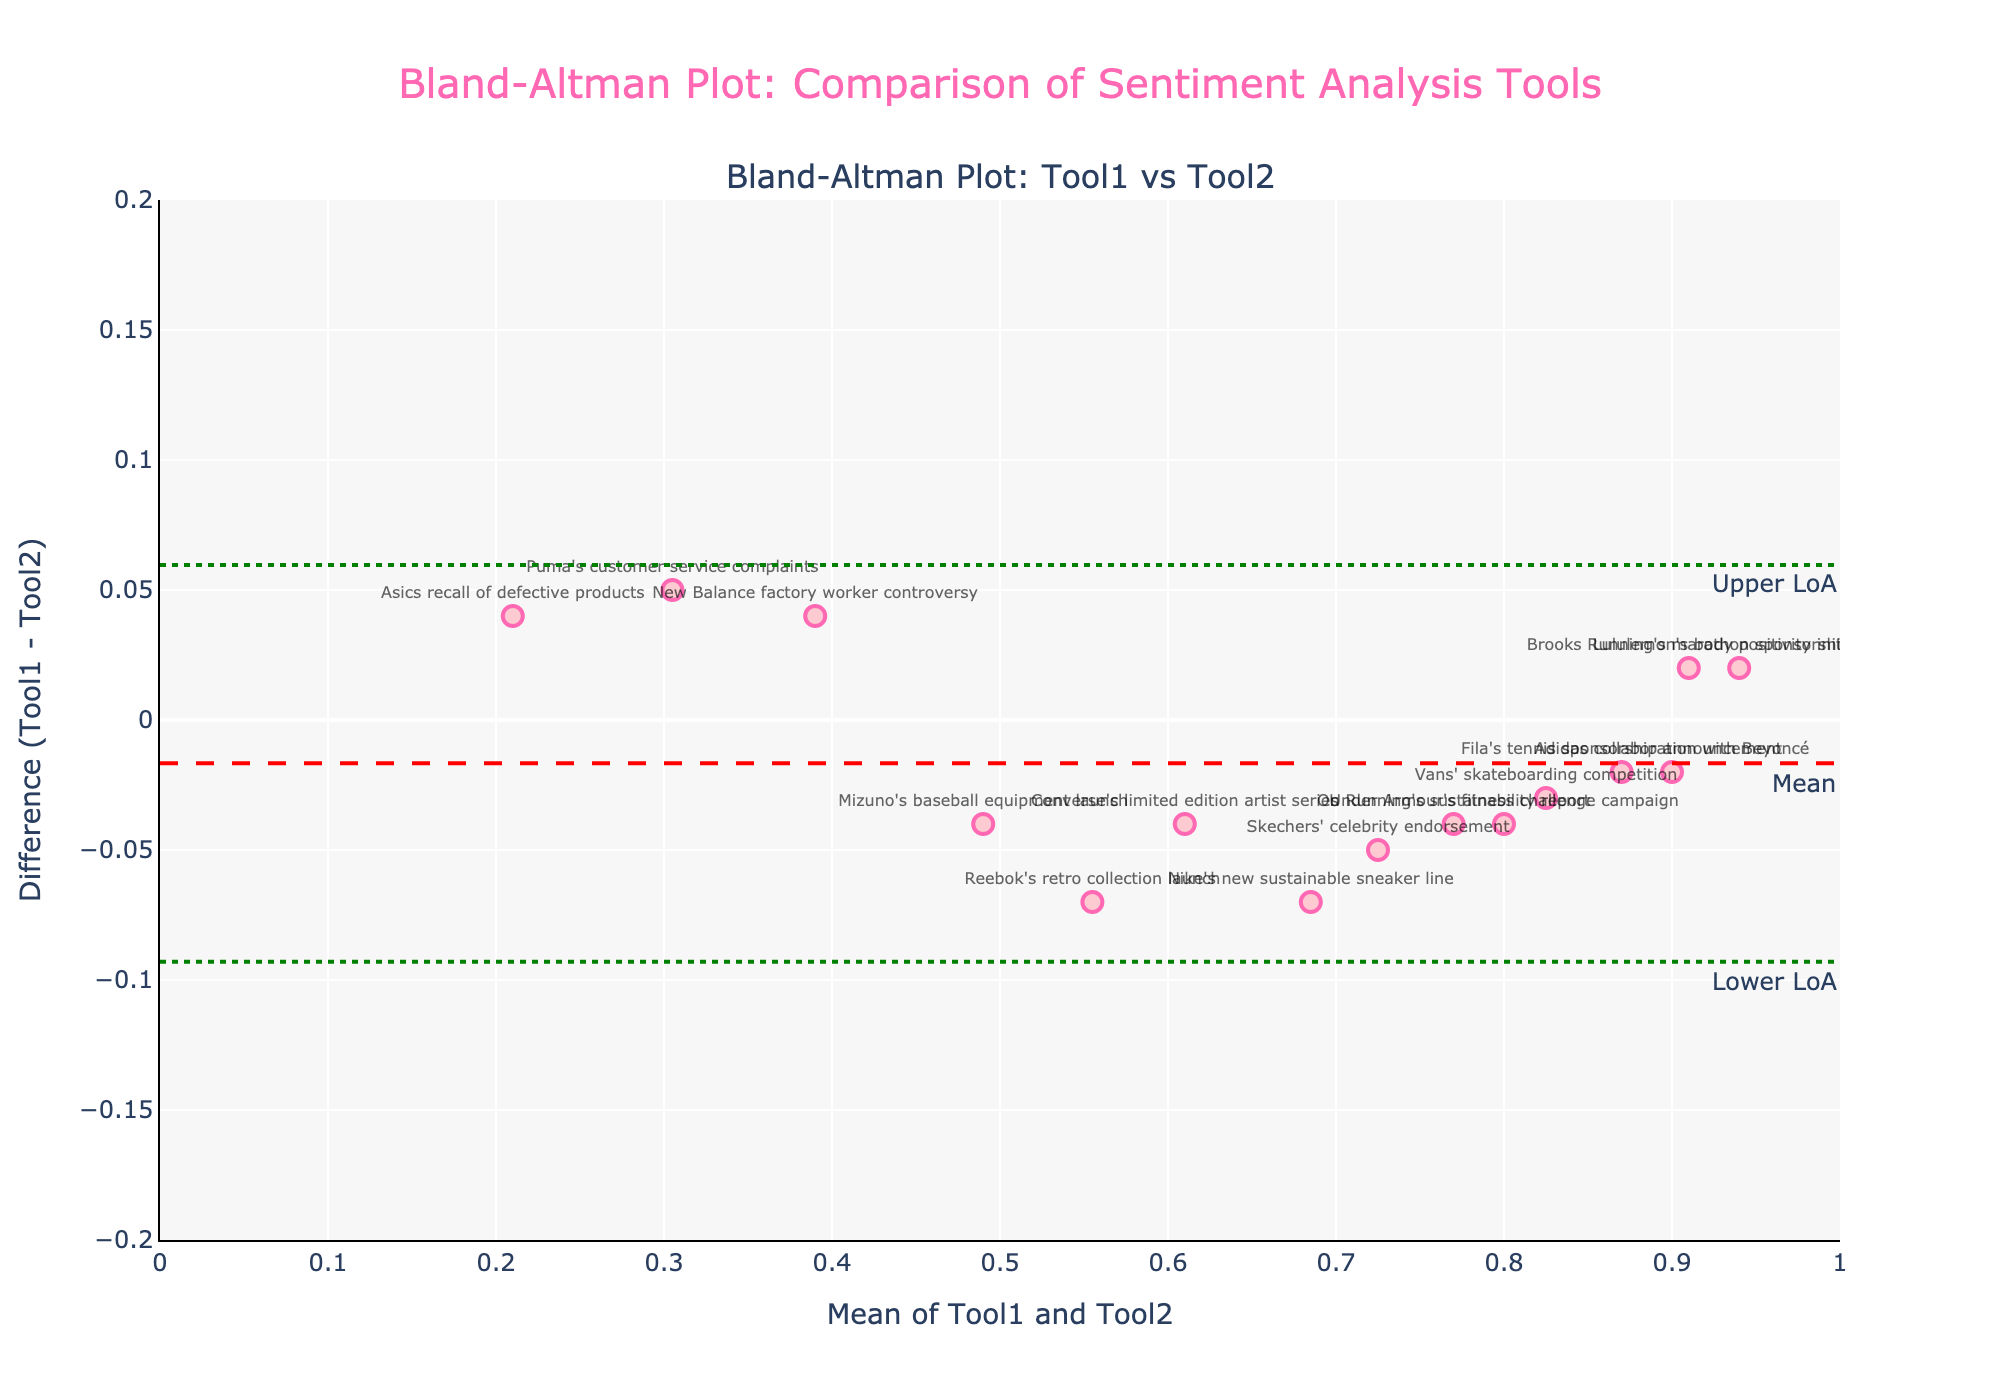What is the title of the plot? The title is displayed at the top of the figure in large pink font. It reads "Bland-Altman Plot: Comparison of Sentiment Analysis Tools".
Answer: Bland-Altman Plot: Comparison of Sentiment Analysis Tools How many brand mentions are represented in the plot? Each marker on the scatter plot corresponds to a brand mention, and there are 15 markers visible.
Answer: 15 What is the y-axis label in the figure? The y-axis label is written alongside the y-axis and reads "Difference (Tool1 - Tool2)".
Answer: Difference (Tool1 - Tool2) What are the upper and lower limits of agreement in the plot? The limits of agreement are indicated by dotted green lines on the plot with annotations that read "Upper LoA" and "Lower LoA". They are located at approximately +0.05 and -0.05, respectively.
Answer: +0.05 and -0.05 Which brand mention has the highest mean score between Tool1 and Tool2? By examining the scatter plot, the brand mention with the highest mean score is near the rightmost edge of the x-axis. Hover text identifies "Lululemon's body positivity initiative" with a mean around 0.94.
Answer: Lululemon's body positivity initiative What is the mean difference between the sentiment scores from Tool1 and Tool2? The mean difference, indicated by a red dashed line and labeled "Mean", is approximately 0.00 on the y-axis.
Answer: 0.00 Which brand mention has the highest positive difference between Tool1 and Tool2 scores? Look for the highest point above the y=0 line. Hover text identifies "Reebok's retro collection launch" with a difference of about +0.07.
Answer: Reebok's retro collection launch Are there any brand mentions with a negative difference between Tool1 and Tool2 scores? Check for points below the y=0 line. There are several such points, e.g., "New Balance factory worker controversy" is among them.
Answer: Yes Which brand mention has a mean sentiment score of around 0.60? Search near the x-axis tick mark for 0.60 and hover over points. "Converse's limited edition artist series" has an approximate mean of 0.61.
Answer: Converse's limited edition artist series Is the difference between Tool1 and Tool2 scores typically close to zero? The majority of points are clustered around the red dashed mean difference line (y=0), indicating most differences are close to zero.
Answer: Yes 